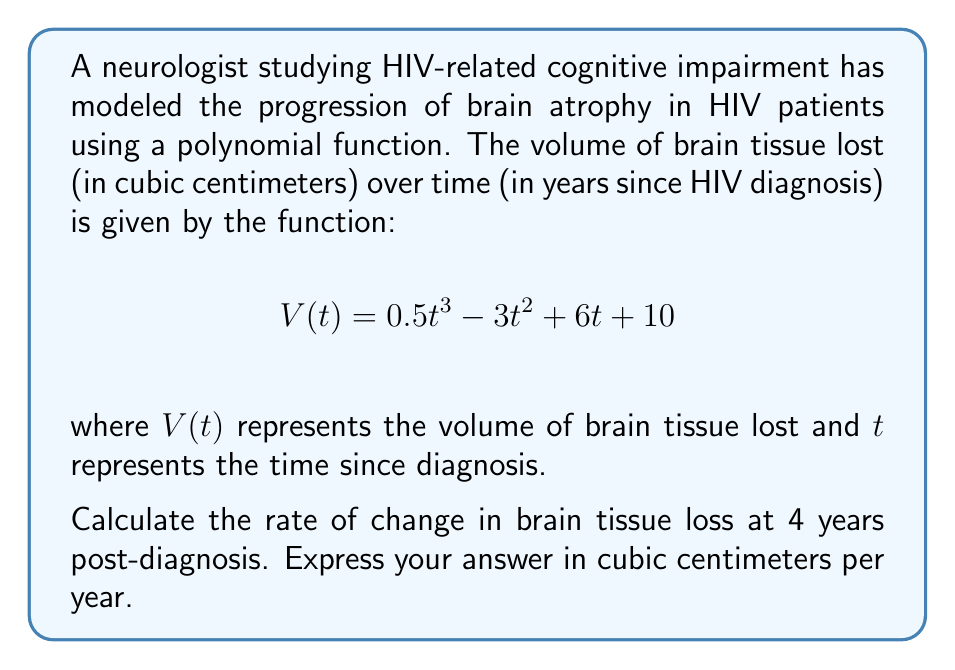Show me your answer to this math problem. To find the rate of change in brain tissue loss at 4 years post-diagnosis, we need to find the derivative of the given function $V(t)$ and evaluate it at $t=4$. Here's the step-by-step process:

1) The given function is:
   $$V(t) = 0.5t^3 - 3t^2 + 6t + 10$$

2) To find the rate of change, we need to differentiate $V(t)$ with respect to $t$:
   $$V'(t) = \frac{d}{dt}(0.5t^3 - 3t^2 + 6t + 10)$$

3) Using the power rule and constant rule of differentiation:
   $$V'(t) = 1.5t^2 - 6t + 6$$

4) This derivative $V'(t)$ represents the instantaneous rate of change of brain tissue loss.

5) To find the rate of change at 4 years post-diagnosis, we evaluate $V'(t)$ at $t=4$:
   $$V'(4) = 1.5(4)^2 - 6(4) + 6$$

6) Simplify:
   $$V'(4) = 1.5(16) - 24 + 6$$
   $$V'(4) = 24 - 24 + 6 = 6$$

Therefore, the rate of change in brain tissue loss at 4 years post-diagnosis is 6 cubic centimeters per year.
Answer: 6 cm³/year 